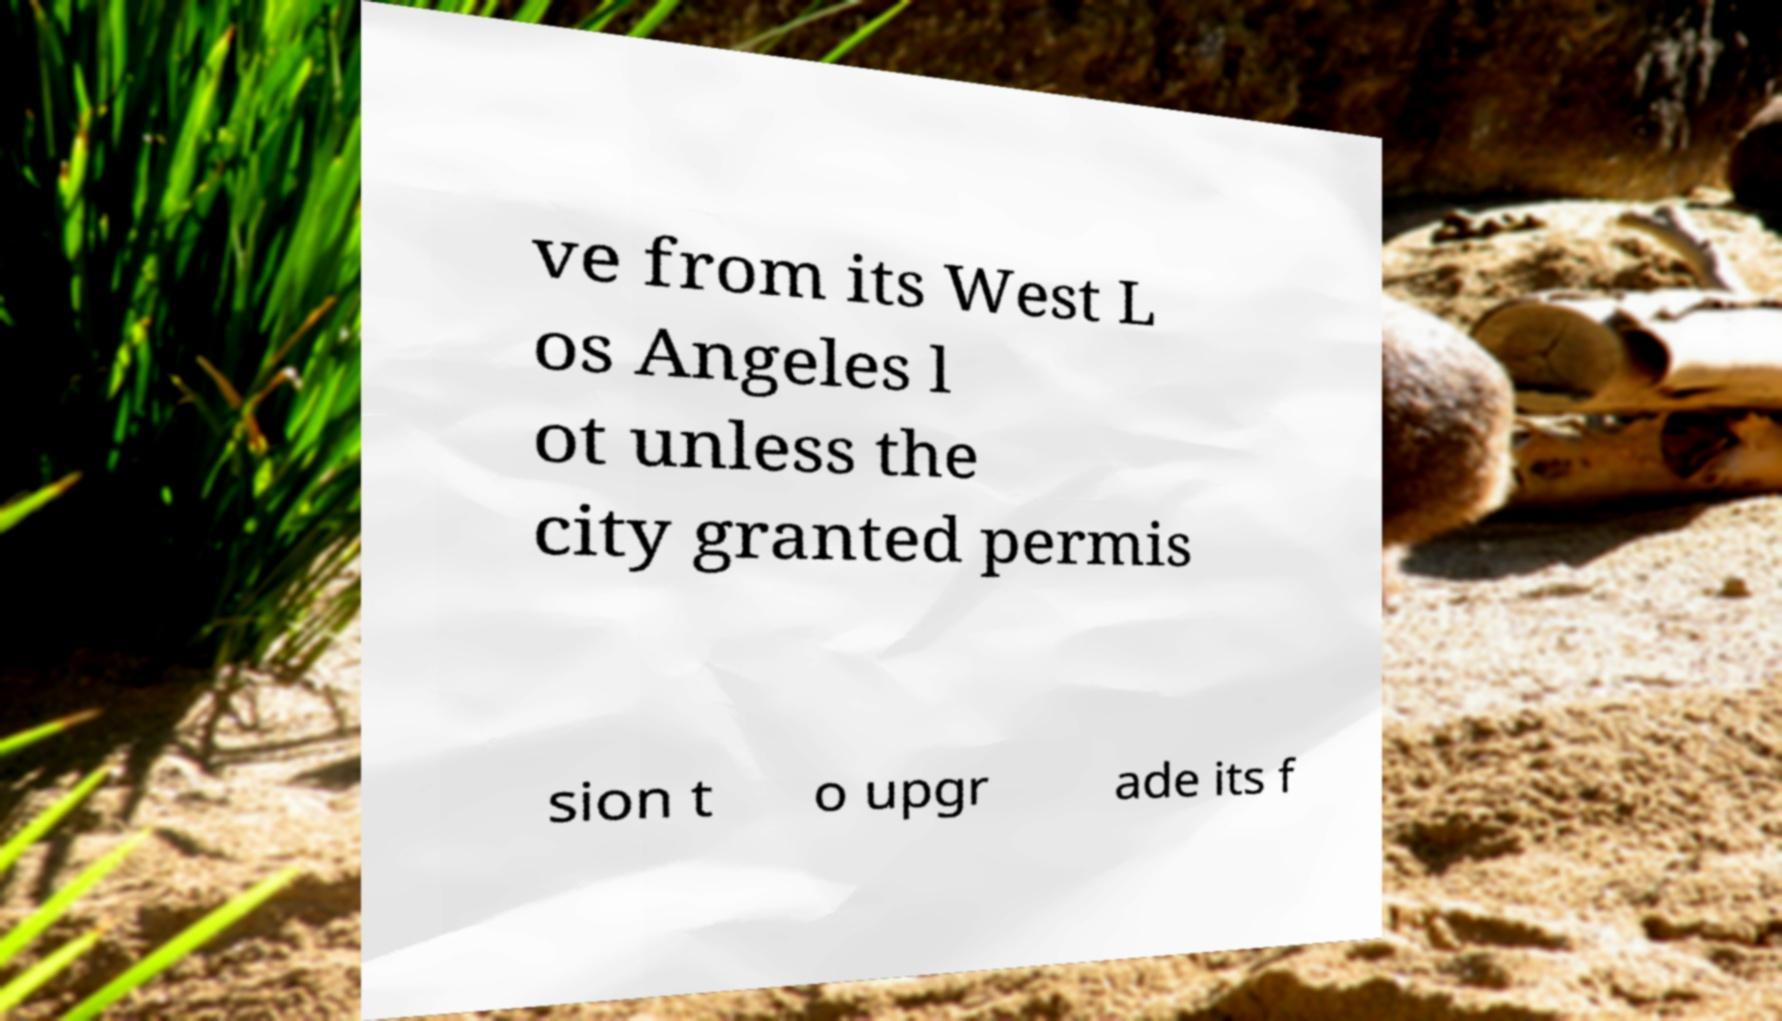Can you read and provide the text displayed in the image?This photo seems to have some interesting text. Can you extract and type it out for me? ve from its West L os Angeles l ot unless the city granted permis sion t o upgr ade its f 